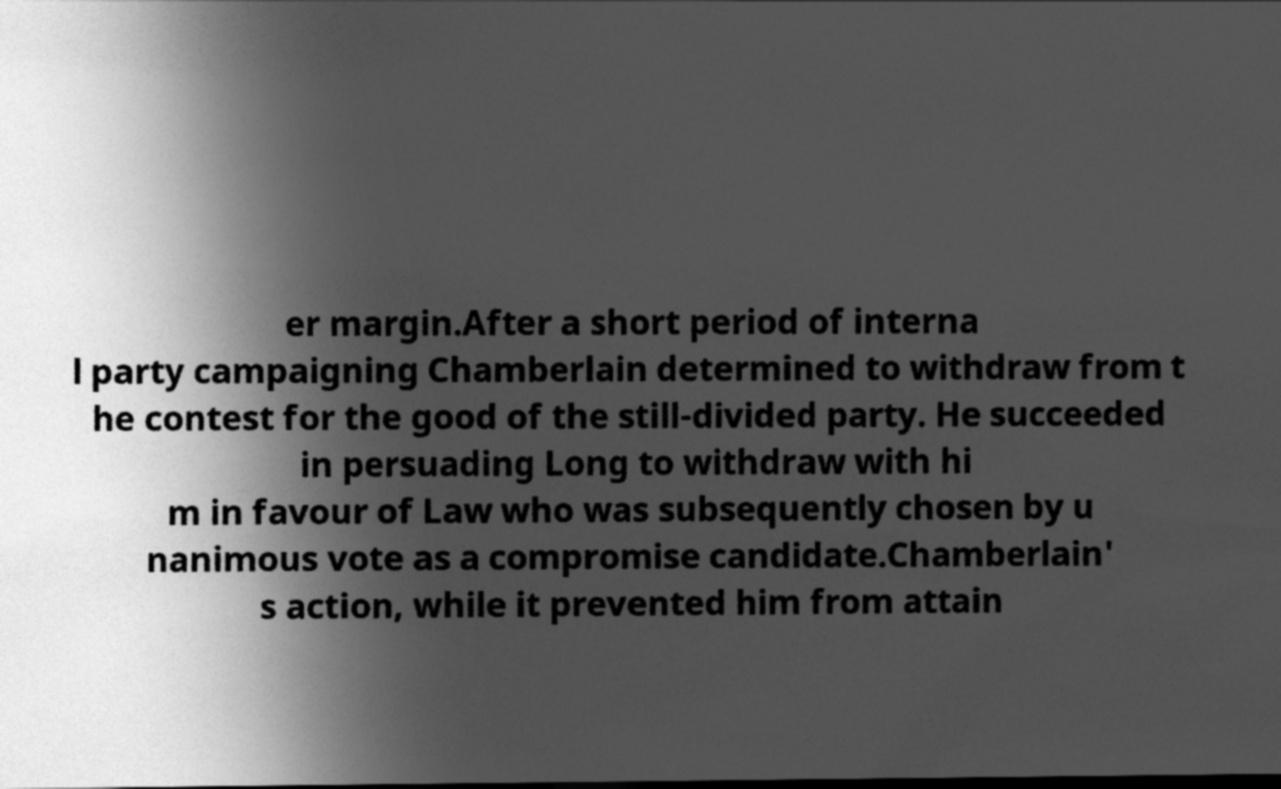Please read and relay the text visible in this image. What does it say? er margin.After a short period of interna l party campaigning Chamberlain determined to withdraw from t he contest for the good of the still-divided party. He succeeded in persuading Long to withdraw with hi m in favour of Law who was subsequently chosen by u nanimous vote as a compromise candidate.Chamberlain' s action, while it prevented him from attain 